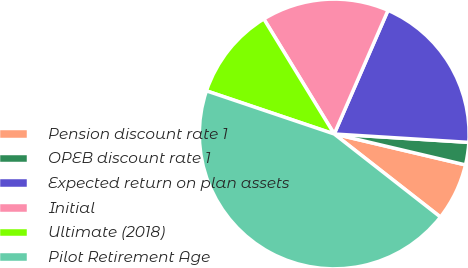Convert chart. <chart><loc_0><loc_0><loc_500><loc_500><pie_chart><fcel>Pension discount rate 1<fcel>OPEB discount rate 1<fcel>Expected return on plan assets<fcel>Initial<fcel>Ultimate (2018)<fcel>Pilot Retirement Age<nl><fcel>6.88%<fcel>2.69%<fcel>19.46%<fcel>15.27%<fcel>11.08%<fcel>44.62%<nl></chart> 